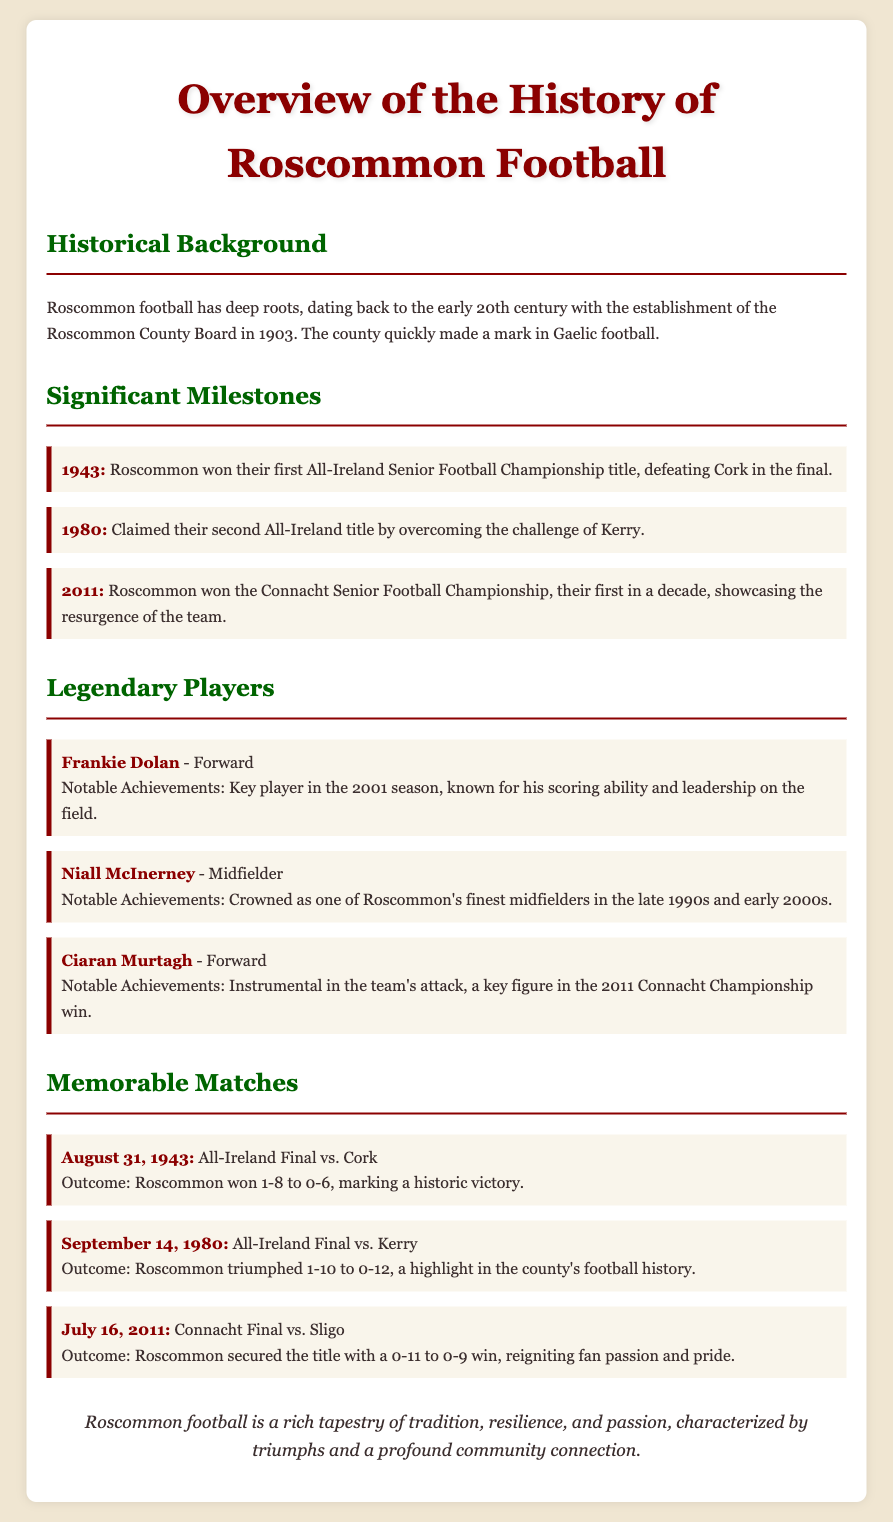What year did Roscommon win their first All-Ireland Senior Football Championship? The document states that Roscommon won their first All-Ireland title in 1943.
Answer: 1943 Who was a key player in the 2001 season? Frankie Dolan is mentioned as a key player in the 2001 season known for his scoring ability.
Answer: Frankie Dolan What significant championship win occurred in 2011? The document notes that Roscommon won the Connacht Senior Football Championship in 2011.
Answer: Connacht Senior Football Championship Which team did Roscommon defeat in the 1980 All-Ireland Final? It is stated that Roscommon overcame the challenge of Kerry in the 1980 All-Ireland Final.
Answer: Kerry On what date did Roscommon secure the Connacht title against Sligo? The document indicates that Roscommon secured the title on July 16, 2011.
Answer: July 16, 2011 What is a notable achievement of Niall McInerney? The document describes Niall McInerney as one of Roscommon's finest midfielders in the late 1990s and early 2000s.
Answer: Finest midfielder What was the outcome of the August 31, 1943 match? The document states that Roscommon won 1-8 to 0-6 against Cork in the All-Ireland Final.
Answer: 1-8 to 0-6 What do the historical milestones highlight about Roscommon football? The milestones showcase important achievements and victories in Roscommon's football history over the decades.
Answer: Achievements and victories 